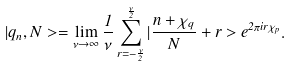Convert formula to latex. <formula><loc_0><loc_0><loc_500><loc_500>| { q } _ { n } , N > = \lim _ { \nu \rightarrow \infty } \frac { 1 } { \nu } \sum _ { r = - \frac { \nu } { 2 } } ^ { \frac { \nu } { 2 } } | \frac { n + \chi _ { q } } N + r > e ^ { 2 \pi i r \chi _ { p } } .</formula> 